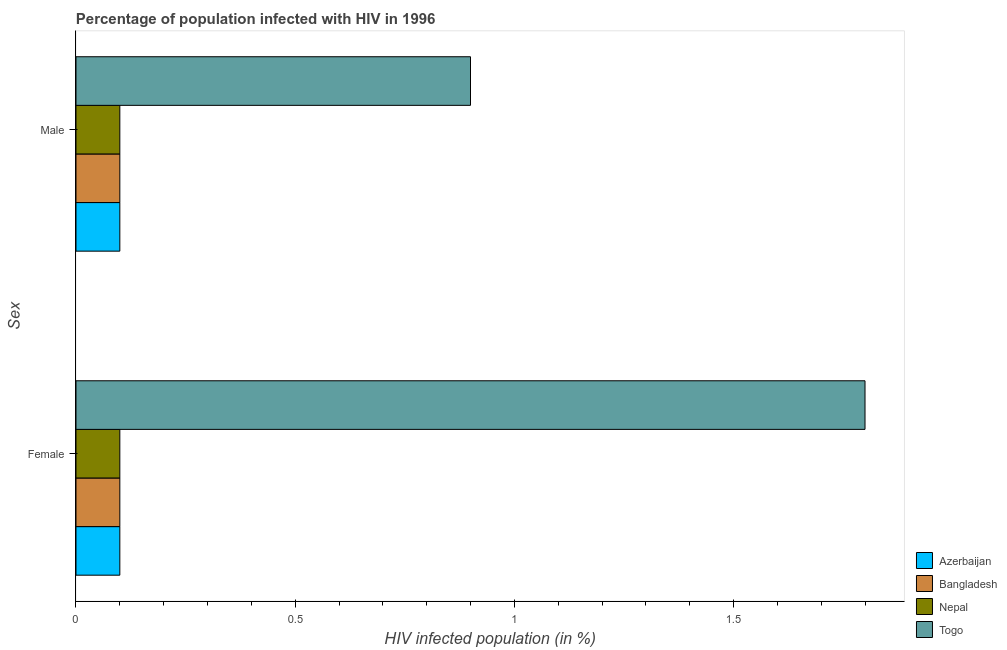How many different coloured bars are there?
Ensure brevity in your answer.  4. How many groups of bars are there?
Provide a short and direct response. 2. What is the label of the 1st group of bars from the top?
Make the answer very short. Male. In which country was the percentage of females who are infected with hiv maximum?
Your answer should be very brief. Togo. In which country was the percentage of males who are infected with hiv minimum?
Keep it short and to the point. Azerbaijan. What is the total percentage of males who are infected with hiv in the graph?
Offer a very short reply. 1.2. What is the difference between the percentage of females who are infected with hiv in Azerbaijan and that in Nepal?
Provide a succinct answer. 0. What is the difference between the percentage of females who are infected with hiv in Togo and the percentage of males who are infected with hiv in Azerbaijan?
Your answer should be compact. 1.7. What is the average percentage of females who are infected with hiv per country?
Offer a very short reply. 0.53. What is the difference between the percentage of males who are infected with hiv and percentage of females who are infected with hiv in Nepal?
Give a very brief answer. 0. What is the ratio of the percentage of males who are infected with hiv in Togo to that in Azerbaijan?
Offer a very short reply. 9. Is the percentage of males who are infected with hiv in Nepal less than that in Azerbaijan?
Provide a succinct answer. No. In how many countries, is the percentage of males who are infected with hiv greater than the average percentage of males who are infected with hiv taken over all countries?
Offer a very short reply. 1. What does the 3rd bar from the top in Female represents?
Provide a succinct answer. Bangladesh. What does the 1st bar from the bottom in Male represents?
Give a very brief answer. Azerbaijan. How many bars are there?
Offer a terse response. 8. What is the difference between two consecutive major ticks on the X-axis?
Provide a succinct answer. 0.5. Does the graph contain any zero values?
Offer a terse response. No. Does the graph contain grids?
Your answer should be very brief. No. Where does the legend appear in the graph?
Make the answer very short. Bottom right. How many legend labels are there?
Offer a terse response. 4. What is the title of the graph?
Give a very brief answer. Percentage of population infected with HIV in 1996. What is the label or title of the X-axis?
Provide a short and direct response. HIV infected population (in %). What is the label or title of the Y-axis?
Provide a short and direct response. Sex. What is the HIV infected population (in %) of Togo in Female?
Provide a short and direct response. 1.8. What is the HIV infected population (in %) of Bangladesh in Male?
Keep it short and to the point. 0.1. What is the HIV infected population (in %) in Nepal in Male?
Provide a short and direct response. 0.1. What is the HIV infected population (in %) of Togo in Male?
Ensure brevity in your answer.  0.9. Across all Sex, what is the maximum HIV infected population (in %) of Bangladesh?
Your answer should be compact. 0.1. Across all Sex, what is the maximum HIV infected population (in %) in Nepal?
Offer a terse response. 0.1. Across all Sex, what is the maximum HIV infected population (in %) of Togo?
Keep it short and to the point. 1.8. Across all Sex, what is the minimum HIV infected population (in %) of Bangladesh?
Offer a very short reply. 0.1. What is the total HIV infected population (in %) in Togo in the graph?
Ensure brevity in your answer.  2.7. What is the difference between the HIV infected population (in %) of Nepal in Female and that in Male?
Provide a succinct answer. 0. What is the difference between the HIV infected population (in %) in Azerbaijan in Female and the HIV infected population (in %) in Bangladesh in Male?
Your response must be concise. 0. What is the difference between the HIV infected population (in %) of Azerbaijan in Female and the HIV infected population (in %) of Nepal in Male?
Provide a short and direct response. 0. What is the difference between the HIV infected population (in %) in Bangladesh in Female and the HIV infected population (in %) in Togo in Male?
Offer a very short reply. -0.8. What is the difference between the HIV infected population (in %) in Nepal in Female and the HIV infected population (in %) in Togo in Male?
Ensure brevity in your answer.  -0.8. What is the average HIV infected population (in %) of Azerbaijan per Sex?
Offer a terse response. 0.1. What is the average HIV infected population (in %) of Nepal per Sex?
Keep it short and to the point. 0.1. What is the average HIV infected population (in %) of Togo per Sex?
Make the answer very short. 1.35. What is the difference between the HIV infected population (in %) in Azerbaijan and HIV infected population (in %) in Nepal in Female?
Offer a very short reply. 0. What is the difference between the HIV infected population (in %) of Bangladesh and HIV infected population (in %) of Nepal in Female?
Keep it short and to the point. 0. What is the difference between the HIV infected population (in %) of Azerbaijan and HIV infected population (in %) of Togo in Male?
Your answer should be compact. -0.8. What is the difference between the HIV infected population (in %) of Bangladesh and HIV infected population (in %) of Togo in Male?
Offer a terse response. -0.8. What is the ratio of the HIV infected population (in %) in Azerbaijan in Female to that in Male?
Offer a very short reply. 1. What is the ratio of the HIV infected population (in %) of Bangladesh in Female to that in Male?
Your answer should be very brief. 1. What is the ratio of the HIV infected population (in %) of Nepal in Female to that in Male?
Provide a succinct answer. 1. What is the difference between the highest and the second highest HIV infected population (in %) in Bangladesh?
Ensure brevity in your answer.  0. What is the difference between the highest and the second highest HIV infected population (in %) of Nepal?
Give a very brief answer. 0. What is the difference between the highest and the second highest HIV infected population (in %) in Togo?
Keep it short and to the point. 0.9. What is the difference between the highest and the lowest HIV infected population (in %) in Bangladesh?
Make the answer very short. 0. What is the difference between the highest and the lowest HIV infected population (in %) of Nepal?
Your answer should be compact. 0. 